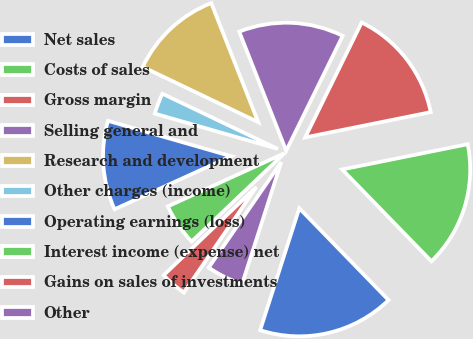Convert chart. <chart><loc_0><loc_0><loc_500><loc_500><pie_chart><fcel>Net sales<fcel>Costs of sales<fcel>Gross margin<fcel>Selling general and<fcel>Research and development<fcel>Other charges (income)<fcel>Operating earnings (loss)<fcel>Interest income (expense) net<fcel>Gains on sales of investments<fcel>Other<nl><fcel>17.22%<fcel>15.89%<fcel>14.57%<fcel>13.25%<fcel>11.92%<fcel>2.65%<fcel>11.26%<fcel>5.3%<fcel>3.31%<fcel>4.64%<nl></chart> 